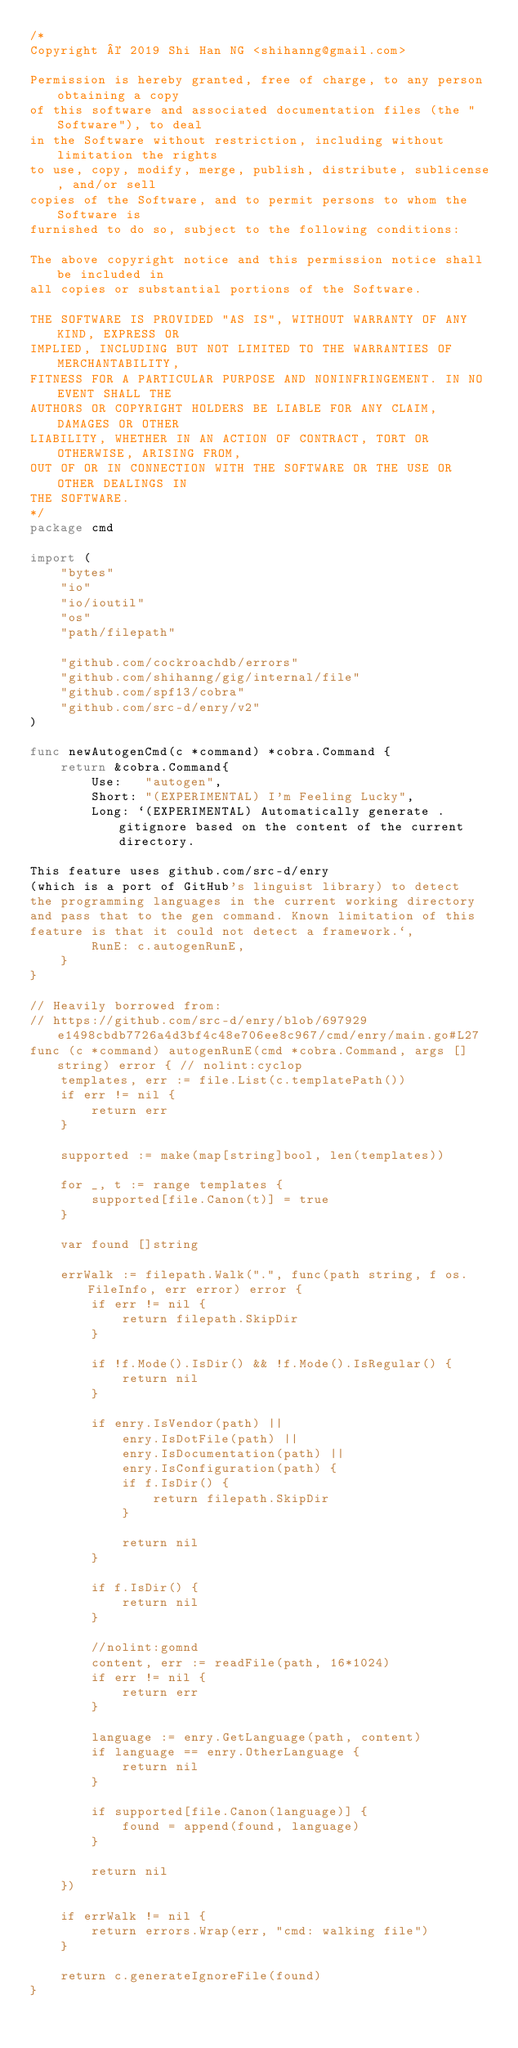<code> <loc_0><loc_0><loc_500><loc_500><_Go_>/*
Copyright © 2019 Shi Han NG <shihanng@gmail.com>

Permission is hereby granted, free of charge, to any person obtaining a copy
of this software and associated documentation files (the "Software"), to deal
in the Software without restriction, including without limitation the rights
to use, copy, modify, merge, publish, distribute, sublicense, and/or sell
copies of the Software, and to permit persons to whom the Software is
furnished to do so, subject to the following conditions:

The above copyright notice and this permission notice shall be included in
all copies or substantial portions of the Software.

THE SOFTWARE IS PROVIDED "AS IS", WITHOUT WARRANTY OF ANY KIND, EXPRESS OR
IMPLIED, INCLUDING BUT NOT LIMITED TO THE WARRANTIES OF MERCHANTABILITY,
FITNESS FOR A PARTICULAR PURPOSE AND NONINFRINGEMENT. IN NO EVENT SHALL THE
AUTHORS OR COPYRIGHT HOLDERS BE LIABLE FOR ANY CLAIM, DAMAGES OR OTHER
LIABILITY, WHETHER IN AN ACTION OF CONTRACT, TORT OR OTHERWISE, ARISING FROM,
OUT OF OR IN CONNECTION WITH THE SOFTWARE OR THE USE OR OTHER DEALINGS IN
THE SOFTWARE.
*/
package cmd

import (
	"bytes"
	"io"
	"io/ioutil"
	"os"
	"path/filepath"

	"github.com/cockroachdb/errors"
	"github.com/shihanng/gig/internal/file"
	"github.com/spf13/cobra"
	"github.com/src-d/enry/v2"
)

func newAutogenCmd(c *command) *cobra.Command {
	return &cobra.Command{
		Use:   "autogen",
		Short: "(EXPERIMENTAL) I'm Feeling Lucky",
		Long: `(EXPERIMENTAL) Automatically generate .gitignore based on the content of the current directory.

This feature uses github.com/src-d/enry
(which is a port of GitHub's linguist library) to detect
the programming languages in the current working directory
and pass that to the gen command. Known limitation of this
feature is that it could not detect a framework.`,
		RunE: c.autogenRunE,
	}
}

// Heavily borrowed from:
// https://github.com/src-d/enry/blob/697929e1498cbdb7726a4d3bf4c48e706ee8c967/cmd/enry/main.go#L27
func (c *command) autogenRunE(cmd *cobra.Command, args []string) error { // nolint:cyclop
	templates, err := file.List(c.templatePath())
	if err != nil {
		return err
	}

	supported := make(map[string]bool, len(templates))

	for _, t := range templates {
		supported[file.Canon(t)] = true
	}

	var found []string

	errWalk := filepath.Walk(".", func(path string, f os.FileInfo, err error) error {
		if err != nil {
			return filepath.SkipDir
		}

		if !f.Mode().IsDir() && !f.Mode().IsRegular() {
			return nil
		}

		if enry.IsVendor(path) ||
			enry.IsDotFile(path) ||
			enry.IsDocumentation(path) ||
			enry.IsConfiguration(path) {
			if f.IsDir() {
				return filepath.SkipDir
			}

			return nil
		}

		if f.IsDir() {
			return nil
		}

		//nolint:gomnd
		content, err := readFile(path, 16*1024)
		if err != nil {
			return err
		}

		language := enry.GetLanguage(path, content)
		if language == enry.OtherLanguage {
			return nil
		}

		if supported[file.Canon(language)] {
			found = append(found, language)
		}

		return nil
	})

	if errWalk != nil {
		return errors.Wrap(err, "cmd: walking file")
	}

	return c.generateIgnoreFile(found)
}
</code> 